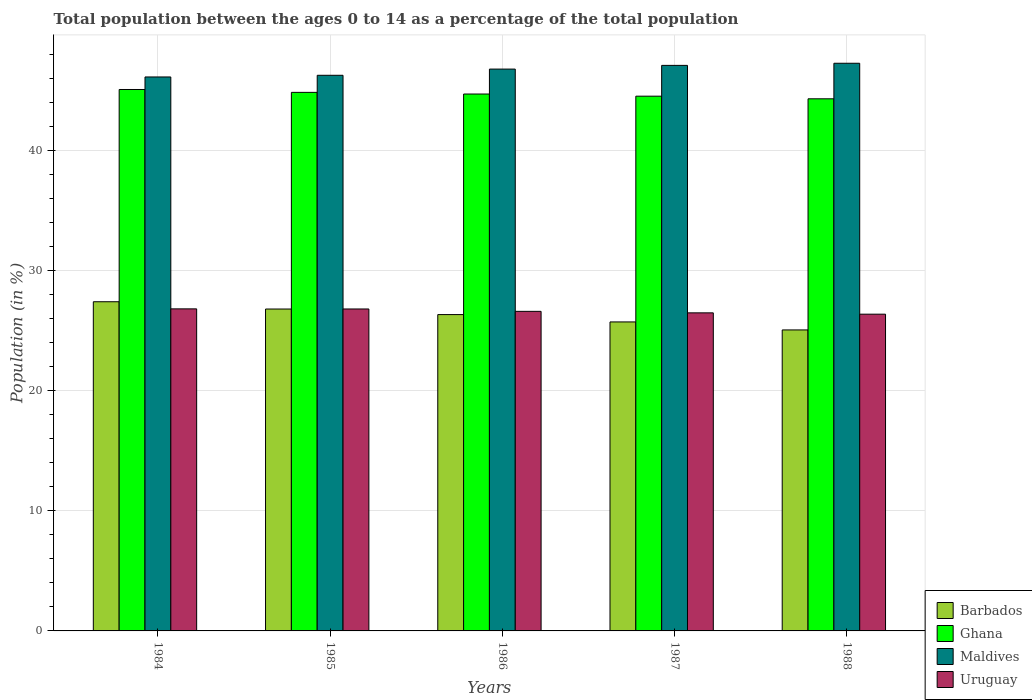How many different coloured bars are there?
Keep it short and to the point. 4. How many groups of bars are there?
Keep it short and to the point. 5. In how many cases, is the number of bars for a given year not equal to the number of legend labels?
Offer a very short reply. 0. What is the percentage of the population ages 0 to 14 in Ghana in 1984?
Ensure brevity in your answer.  45.09. Across all years, what is the maximum percentage of the population ages 0 to 14 in Barbados?
Ensure brevity in your answer.  27.42. Across all years, what is the minimum percentage of the population ages 0 to 14 in Ghana?
Your answer should be compact. 44.32. What is the total percentage of the population ages 0 to 14 in Uruguay in the graph?
Give a very brief answer. 133.13. What is the difference between the percentage of the population ages 0 to 14 in Ghana in 1987 and that in 1988?
Your answer should be compact. 0.22. What is the difference between the percentage of the population ages 0 to 14 in Barbados in 1987 and the percentage of the population ages 0 to 14 in Maldives in 1984?
Provide a short and direct response. -20.4. What is the average percentage of the population ages 0 to 14 in Barbados per year?
Your response must be concise. 26.28. In the year 1985, what is the difference between the percentage of the population ages 0 to 14 in Maldives and percentage of the population ages 0 to 14 in Uruguay?
Offer a terse response. 19.46. What is the ratio of the percentage of the population ages 0 to 14 in Ghana in 1984 to that in 1988?
Your answer should be compact. 1.02. What is the difference between the highest and the second highest percentage of the population ages 0 to 14 in Uruguay?
Give a very brief answer. 0.01. What is the difference between the highest and the lowest percentage of the population ages 0 to 14 in Uruguay?
Keep it short and to the point. 0.44. Is the sum of the percentage of the population ages 0 to 14 in Uruguay in 1985 and 1986 greater than the maximum percentage of the population ages 0 to 14 in Maldives across all years?
Ensure brevity in your answer.  Yes. Is it the case that in every year, the sum of the percentage of the population ages 0 to 14 in Barbados and percentage of the population ages 0 to 14 in Ghana is greater than the sum of percentage of the population ages 0 to 14 in Uruguay and percentage of the population ages 0 to 14 in Maldives?
Provide a succinct answer. Yes. What does the 3rd bar from the left in 1984 represents?
Keep it short and to the point. Maldives. What does the 1st bar from the right in 1985 represents?
Give a very brief answer. Uruguay. Is it the case that in every year, the sum of the percentage of the population ages 0 to 14 in Barbados and percentage of the population ages 0 to 14 in Ghana is greater than the percentage of the population ages 0 to 14 in Maldives?
Provide a succinct answer. Yes. How many years are there in the graph?
Keep it short and to the point. 5. Does the graph contain any zero values?
Your answer should be very brief. No. Where does the legend appear in the graph?
Provide a short and direct response. Bottom right. How many legend labels are there?
Provide a short and direct response. 4. What is the title of the graph?
Offer a very short reply. Total population between the ages 0 to 14 as a percentage of the total population. Does "Cabo Verde" appear as one of the legend labels in the graph?
Offer a terse response. No. What is the Population (in %) in Barbados in 1984?
Ensure brevity in your answer.  27.42. What is the Population (in %) in Ghana in 1984?
Your answer should be very brief. 45.09. What is the Population (in %) of Maldives in 1984?
Your response must be concise. 46.14. What is the Population (in %) of Uruguay in 1984?
Provide a short and direct response. 26.82. What is the Population (in %) of Barbados in 1985?
Give a very brief answer. 26.81. What is the Population (in %) of Ghana in 1985?
Provide a succinct answer. 44.86. What is the Population (in %) in Maldives in 1985?
Your response must be concise. 46.28. What is the Population (in %) of Uruguay in 1985?
Offer a very short reply. 26.81. What is the Population (in %) of Barbados in 1986?
Offer a terse response. 26.35. What is the Population (in %) in Ghana in 1986?
Provide a succinct answer. 44.72. What is the Population (in %) of Maldives in 1986?
Offer a very short reply. 46.79. What is the Population (in %) in Uruguay in 1986?
Give a very brief answer. 26.62. What is the Population (in %) in Barbados in 1987?
Your response must be concise. 25.74. What is the Population (in %) of Ghana in 1987?
Your response must be concise. 44.54. What is the Population (in %) in Maldives in 1987?
Provide a short and direct response. 47.1. What is the Population (in %) in Uruguay in 1987?
Keep it short and to the point. 26.49. What is the Population (in %) of Barbados in 1988?
Ensure brevity in your answer.  25.07. What is the Population (in %) of Ghana in 1988?
Your answer should be very brief. 44.32. What is the Population (in %) of Maldives in 1988?
Make the answer very short. 47.28. What is the Population (in %) in Uruguay in 1988?
Make the answer very short. 26.38. Across all years, what is the maximum Population (in %) of Barbados?
Provide a succinct answer. 27.42. Across all years, what is the maximum Population (in %) of Ghana?
Give a very brief answer. 45.09. Across all years, what is the maximum Population (in %) in Maldives?
Offer a very short reply. 47.28. Across all years, what is the maximum Population (in %) in Uruguay?
Offer a terse response. 26.82. Across all years, what is the minimum Population (in %) of Barbados?
Your answer should be compact. 25.07. Across all years, what is the minimum Population (in %) in Ghana?
Your answer should be compact. 44.32. Across all years, what is the minimum Population (in %) in Maldives?
Ensure brevity in your answer.  46.14. Across all years, what is the minimum Population (in %) in Uruguay?
Offer a very short reply. 26.38. What is the total Population (in %) in Barbados in the graph?
Give a very brief answer. 131.38. What is the total Population (in %) of Ghana in the graph?
Make the answer very short. 223.52. What is the total Population (in %) of Maldives in the graph?
Your answer should be compact. 233.59. What is the total Population (in %) in Uruguay in the graph?
Your answer should be compact. 133.13. What is the difference between the Population (in %) in Barbados in 1984 and that in 1985?
Keep it short and to the point. 0.61. What is the difference between the Population (in %) in Ghana in 1984 and that in 1985?
Give a very brief answer. 0.24. What is the difference between the Population (in %) of Maldives in 1984 and that in 1985?
Provide a short and direct response. -0.14. What is the difference between the Population (in %) in Uruguay in 1984 and that in 1985?
Offer a very short reply. 0.01. What is the difference between the Population (in %) of Barbados in 1984 and that in 1986?
Your answer should be very brief. 1.07. What is the difference between the Population (in %) of Ghana in 1984 and that in 1986?
Provide a short and direct response. 0.38. What is the difference between the Population (in %) of Maldives in 1984 and that in 1986?
Your response must be concise. -0.66. What is the difference between the Population (in %) of Uruguay in 1984 and that in 1986?
Make the answer very short. 0.21. What is the difference between the Population (in %) of Barbados in 1984 and that in 1987?
Ensure brevity in your answer.  1.68. What is the difference between the Population (in %) in Ghana in 1984 and that in 1987?
Provide a short and direct response. 0.56. What is the difference between the Population (in %) of Maldives in 1984 and that in 1987?
Your response must be concise. -0.96. What is the difference between the Population (in %) in Uruguay in 1984 and that in 1987?
Provide a succinct answer. 0.33. What is the difference between the Population (in %) of Barbados in 1984 and that in 1988?
Your response must be concise. 2.35. What is the difference between the Population (in %) of Ghana in 1984 and that in 1988?
Provide a succinct answer. 0.78. What is the difference between the Population (in %) in Maldives in 1984 and that in 1988?
Keep it short and to the point. -1.14. What is the difference between the Population (in %) in Uruguay in 1984 and that in 1988?
Your answer should be very brief. 0.44. What is the difference between the Population (in %) in Barbados in 1985 and that in 1986?
Your response must be concise. 0.46. What is the difference between the Population (in %) in Ghana in 1985 and that in 1986?
Provide a succinct answer. 0.14. What is the difference between the Population (in %) in Maldives in 1985 and that in 1986?
Ensure brevity in your answer.  -0.52. What is the difference between the Population (in %) of Uruguay in 1985 and that in 1986?
Offer a terse response. 0.2. What is the difference between the Population (in %) in Barbados in 1985 and that in 1987?
Your response must be concise. 1.07. What is the difference between the Population (in %) in Ghana in 1985 and that in 1987?
Offer a very short reply. 0.32. What is the difference between the Population (in %) of Maldives in 1985 and that in 1987?
Provide a succinct answer. -0.82. What is the difference between the Population (in %) of Uruguay in 1985 and that in 1987?
Make the answer very short. 0.32. What is the difference between the Population (in %) in Barbados in 1985 and that in 1988?
Give a very brief answer. 1.74. What is the difference between the Population (in %) in Ghana in 1985 and that in 1988?
Your response must be concise. 0.54. What is the difference between the Population (in %) of Maldives in 1985 and that in 1988?
Offer a very short reply. -1. What is the difference between the Population (in %) in Uruguay in 1985 and that in 1988?
Provide a succinct answer. 0.43. What is the difference between the Population (in %) of Barbados in 1986 and that in 1987?
Provide a succinct answer. 0.61. What is the difference between the Population (in %) in Ghana in 1986 and that in 1987?
Ensure brevity in your answer.  0.18. What is the difference between the Population (in %) in Maldives in 1986 and that in 1987?
Keep it short and to the point. -0.31. What is the difference between the Population (in %) of Uruguay in 1986 and that in 1987?
Make the answer very short. 0.12. What is the difference between the Population (in %) of Barbados in 1986 and that in 1988?
Your answer should be very brief. 1.28. What is the difference between the Population (in %) in Ghana in 1986 and that in 1988?
Offer a very short reply. 0.4. What is the difference between the Population (in %) in Maldives in 1986 and that in 1988?
Offer a very short reply. -0.49. What is the difference between the Population (in %) in Uruguay in 1986 and that in 1988?
Provide a succinct answer. 0.23. What is the difference between the Population (in %) of Barbados in 1987 and that in 1988?
Your answer should be compact. 0.67. What is the difference between the Population (in %) of Ghana in 1987 and that in 1988?
Your answer should be compact. 0.22. What is the difference between the Population (in %) in Maldives in 1987 and that in 1988?
Make the answer very short. -0.18. What is the difference between the Population (in %) in Uruguay in 1987 and that in 1988?
Provide a short and direct response. 0.11. What is the difference between the Population (in %) in Barbados in 1984 and the Population (in %) in Ghana in 1985?
Your response must be concise. -17.44. What is the difference between the Population (in %) in Barbados in 1984 and the Population (in %) in Maldives in 1985?
Your response must be concise. -18.86. What is the difference between the Population (in %) in Barbados in 1984 and the Population (in %) in Uruguay in 1985?
Provide a short and direct response. 0.6. What is the difference between the Population (in %) of Ghana in 1984 and the Population (in %) of Maldives in 1985?
Provide a short and direct response. -1.18. What is the difference between the Population (in %) in Ghana in 1984 and the Population (in %) in Uruguay in 1985?
Your answer should be compact. 18.28. What is the difference between the Population (in %) of Maldives in 1984 and the Population (in %) of Uruguay in 1985?
Make the answer very short. 19.32. What is the difference between the Population (in %) of Barbados in 1984 and the Population (in %) of Ghana in 1986?
Your answer should be very brief. -17.3. What is the difference between the Population (in %) of Barbados in 1984 and the Population (in %) of Maldives in 1986?
Provide a succinct answer. -19.38. What is the difference between the Population (in %) in Barbados in 1984 and the Population (in %) in Uruguay in 1986?
Ensure brevity in your answer.  0.8. What is the difference between the Population (in %) of Ghana in 1984 and the Population (in %) of Maldives in 1986?
Offer a very short reply. -1.7. What is the difference between the Population (in %) in Ghana in 1984 and the Population (in %) in Uruguay in 1986?
Keep it short and to the point. 18.48. What is the difference between the Population (in %) in Maldives in 1984 and the Population (in %) in Uruguay in 1986?
Make the answer very short. 19.52. What is the difference between the Population (in %) in Barbados in 1984 and the Population (in %) in Ghana in 1987?
Give a very brief answer. -17.12. What is the difference between the Population (in %) of Barbados in 1984 and the Population (in %) of Maldives in 1987?
Offer a terse response. -19.69. What is the difference between the Population (in %) in Barbados in 1984 and the Population (in %) in Uruguay in 1987?
Offer a terse response. 0.93. What is the difference between the Population (in %) in Ghana in 1984 and the Population (in %) in Maldives in 1987?
Offer a very short reply. -2.01. What is the difference between the Population (in %) of Ghana in 1984 and the Population (in %) of Uruguay in 1987?
Keep it short and to the point. 18.6. What is the difference between the Population (in %) of Maldives in 1984 and the Population (in %) of Uruguay in 1987?
Your answer should be compact. 19.65. What is the difference between the Population (in %) of Barbados in 1984 and the Population (in %) of Ghana in 1988?
Offer a very short reply. -16.9. What is the difference between the Population (in %) of Barbados in 1984 and the Population (in %) of Maldives in 1988?
Make the answer very short. -19.86. What is the difference between the Population (in %) in Barbados in 1984 and the Population (in %) in Uruguay in 1988?
Your answer should be compact. 1.04. What is the difference between the Population (in %) of Ghana in 1984 and the Population (in %) of Maldives in 1988?
Offer a very short reply. -2.19. What is the difference between the Population (in %) of Ghana in 1984 and the Population (in %) of Uruguay in 1988?
Provide a short and direct response. 18.71. What is the difference between the Population (in %) of Maldives in 1984 and the Population (in %) of Uruguay in 1988?
Offer a very short reply. 19.76. What is the difference between the Population (in %) in Barbados in 1985 and the Population (in %) in Ghana in 1986?
Ensure brevity in your answer.  -17.91. What is the difference between the Population (in %) of Barbados in 1985 and the Population (in %) of Maldives in 1986?
Offer a terse response. -19.98. What is the difference between the Population (in %) of Barbados in 1985 and the Population (in %) of Uruguay in 1986?
Your answer should be very brief. 0.19. What is the difference between the Population (in %) in Ghana in 1985 and the Population (in %) in Maldives in 1986?
Ensure brevity in your answer.  -1.94. What is the difference between the Population (in %) of Ghana in 1985 and the Population (in %) of Uruguay in 1986?
Provide a succinct answer. 18.24. What is the difference between the Population (in %) in Maldives in 1985 and the Population (in %) in Uruguay in 1986?
Offer a terse response. 19.66. What is the difference between the Population (in %) of Barbados in 1985 and the Population (in %) of Ghana in 1987?
Provide a succinct answer. -17.73. What is the difference between the Population (in %) of Barbados in 1985 and the Population (in %) of Maldives in 1987?
Keep it short and to the point. -20.29. What is the difference between the Population (in %) in Barbados in 1985 and the Population (in %) in Uruguay in 1987?
Offer a terse response. 0.32. What is the difference between the Population (in %) of Ghana in 1985 and the Population (in %) of Maldives in 1987?
Ensure brevity in your answer.  -2.25. What is the difference between the Population (in %) in Ghana in 1985 and the Population (in %) in Uruguay in 1987?
Your response must be concise. 18.36. What is the difference between the Population (in %) of Maldives in 1985 and the Population (in %) of Uruguay in 1987?
Keep it short and to the point. 19.79. What is the difference between the Population (in %) in Barbados in 1985 and the Population (in %) in Ghana in 1988?
Keep it short and to the point. -17.51. What is the difference between the Population (in %) in Barbados in 1985 and the Population (in %) in Maldives in 1988?
Your answer should be compact. -20.47. What is the difference between the Population (in %) in Barbados in 1985 and the Population (in %) in Uruguay in 1988?
Provide a succinct answer. 0.43. What is the difference between the Population (in %) of Ghana in 1985 and the Population (in %) of Maldives in 1988?
Your response must be concise. -2.42. What is the difference between the Population (in %) of Ghana in 1985 and the Population (in %) of Uruguay in 1988?
Provide a succinct answer. 18.47. What is the difference between the Population (in %) in Maldives in 1985 and the Population (in %) in Uruguay in 1988?
Offer a very short reply. 19.9. What is the difference between the Population (in %) of Barbados in 1986 and the Population (in %) of Ghana in 1987?
Make the answer very short. -18.19. What is the difference between the Population (in %) of Barbados in 1986 and the Population (in %) of Maldives in 1987?
Provide a succinct answer. -20.76. What is the difference between the Population (in %) of Barbados in 1986 and the Population (in %) of Uruguay in 1987?
Provide a short and direct response. -0.14. What is the difference between the Population (in %) in Ghana in 1986 and the Population (in %) in Maldives in 1987?
Provide a succinct answer. -2.38. What is the difference between the Population (in %) of Ghana in 1986 and the Population (in %) of Uruguay in 1987?
Make the answer very short. 18.23. What is the difference between the Population (in %) in Maldives in 1986 and the Population (in %) in Uruguay in 1987?
Your answer should be very brief. 20.3. What is the difference between the Population (in %) of Barbados in 1986 and the Population (in %) of Ghana in 1988?
Your answer should be very brief. -17.97. What is the difference between the Population (in %) in Barbados in 1986 and the Population (in %) in Maldives in 1988?
Ensure brevity in your answer.  -20.93. What is the difference between the Population (in %) of Barbados in 1986 and the Population (in %) of Uruguay in 1988?
Your answer should be compact. -0.03. What is the difference between the Population (in %) in Ghana in 1986 and the Population (in %) in Maldives in 1988?
Provide a short and direct response. -2.56. What is the difference between the Population (in %) in Ghana in 1986 and the Population (in %) in Uruguay in 1988?
Your answer should be compact. 18.34. What is the difference between the Population (in %) in Maldives in 1986 and the Population (in %) in Uruguay in 1988?
Keep it short and to the point. 20.41. What is the difference between the Population (in %) of Barbados in 1987 and the Population (in %) of Ghana in 1988?
Your answer should be compact. -18.58. What is the difference between the Population (in %) of Barbados in 1987 and the Population (in %) of Maldives in 1988?
Your response must be concise. -21.54. What is the difference between the Population (in %) in Barbados in 1987 and the Population (in %) in Uruguay in 1988?
Your answer should be very brief. -0.65. What is the difference between the Population (in %) in Ghana in 1987 and the Population (in %) in Maldives in 1988?
Provide a short and direct response. -2.74. What is the difference between the Population (in %) in Ghana in 1987 and the Population (in %) in Uruguay in 1988?
Provide a short and direct response. 18.16. What is the difference between the Population (in %) in Maldives in 1987 and the Population (in %) in Uruguay in 1988?
Give a very brief answer. 20.72. What is the average Population (in %) in Barbados per year?
Your response must be concise. 26.28. What is the average Population (in %) in Ghana per year?
Give a very brief answer. 44.7. What is the average Population (in %) of Maldives per year?
Offer a very short reply. 46.72. What is the average Population (in %) of Uruguay per year?
Keep it short and to the point. 26.63. In the year 1984, what is the difference between the Population (in %) of Barbados and Population (in %) of Ghana?
Your answer should be very brief. -17.68. In the year 1984, what is the difference between the Population (in %) in Barbados and Population (in %) in Maldives?
Give a very brief answer. -18.72. In the year 1984, what is the difference between the Population (in %) of Barbados and Population (in %) of Uruguay?
Give a very brief answer. 0.59. In the year 1984, what is the difference between the Population (in %) in Ghana and Population (in %) in Maldives?
Your answer should be very brief. -1.04. In the year 1984, what is the difference between the Population (in %) of Ghana and Population (in %) of Uruguay?
Keep it short and to the point. 18.27. In the year 1984, what is the difference between the Population (in %) of Maldives and Population (in %) of Uruguay?
Your answer should be compact. 19.31. In the year 1985, what is the difference between the Population (in %) of Barbados and Population (in %) of Ghana?
Offer a terse response. -18.05. In the year 1985, what is the difference between the Population (in %) of Barbados and Population (in %) of Maldives?
Offer a very short reply. -19.47. In the year 1985, what is the difference between the Population (in %) in Barbados and Population (in %) in Uruguay?
Provide a short and direct response. -0. In the year 1985, what is the difference between the Population (in %) in Ghana and Population (in %) in Maldives?
Keep it short and to the point. -1.42. In the year 1985, what is the difference between the Population (in %) of Ghana and Population (in %) of Uruguay?
Your answer should be compact. 18.04. In the year 1985, what is the difference between the Population (in %) of Maldives and Population (in %) of Uruguay?
Make the answer very short. 19.46. In the year 1986, what is the difference between the Population (in %) of Barbados and Population (in %) of Ghana?
Offer a terse response. -18.37. In the year 1986, what is the difference between the Population (in %) in Barbados and Population (in %) in Maldives?
Provide a succinct answer. -20.45. In the year 1986, what is the difference between the Population (in %) in Barbados and Population (in %) in Uruguay?
Keep it short and to the point. -0.27. In the year 1986, what is the difference between the Population (in %) of Ghana and Population (in %) of Maldives?
Provide a short and direct response. -2.08. In the year 1986, what is the difference between the Population (in %) in Ghana and Population (in %) in Uruguay?
Provide a succinct answer. 18.1. In the year 1986, what is the difference between the Population (in %) of Maldives and Population (in %) of Uruguay?
Offer a very short reply. 20.18. In the year 1987, what is the difference between the Population (in %) in Barbados and Population (in %) in Ghana?
Ensure brevity in your answer.  -18.8. In the year 1987, what is the difference between the Population (in %) in Barbados and Population (in %) in Maldives?
Provide a succinct answer. -21.37. In the year 1987, what is the difference between the Population (in %) in Barbados and Population (in %) in Uruguay?
Your answer should be very brief. -0.76. In the year 1987, what is the difference between the Population (in %) of Ghana and Population (in %) of Maldives?
Ensure brevity in your answer.  -2.57. In the year 1987, what is the difference between the Population (in %) in Ghana and Population (in %) in Uruguay?
Give a very brief answer. 18.05. In the year 1987, what is the difference between the Population (in %) of Maldives and Population (in %) of Uruguay?
Make the answer very short. 20.61. In the year 1988, what is the difference between the Population (in %) of Barbados and Population (in %) of Ghana?
Your response must be concise. -19.25. In the year 1988, what is the difference between the Population (in %) of Barbados and Population (in %) of Maldives?
Ensure brevity in your answer.  -22.21. In the year 1988, what is the difference between the Population (in %) in Barbados and Population (in %) in Uruguay?
Offer a terse response. -1.31. In the year 1988, what is the difference between the Population (in %) of Ghana and Population (in %) of Maldives?
Provide a short and direct response. -2.96. In the year 1988, what is the difference between the Population (in %) in Ghana and Population (in %) in Uruguay?
Offer a very short reply. 17.94. In the year 1988, what is the difference between the Population (in %) of Maldives and Population (in %) of Uruguay?
Offer a very short reply. 20.9. What is the ratio of the Population (in %) in Barbados in 1984 to that in 1985?
Keep it short and to the point. 1.02. What is the ratio of the Population (in %) in Barbados in 1984 to that in 1986?
Offer a terse response. 1.04. What is the ratio of the Population (in %) of Ghana in 1984 to that in 1986?
Offer a very short reply. 1.01. What is the ratio of the Population (in %) of Maldives in 1984 to that in 1986?
Provide a succinct answer. 0.99. What is the ratio of the Population (in %) in Uruguay in 1984 to that in 1986?
Ensure brevity in your answer.  1.01. What is the ratio of the Population (in %) in Barbados in 1984 to that in 1987?
Make the answer very short. 1.07. What is the ratio of the Population (in %) of Ghana in 1984 to that in 1987?
Offer a very short reply. 1.01. What is the ratio of the Population (in %) in Maldives in 1984 to that in 1987?
Ensure brevity in your answer.  0.98. What is the ratio of the Population (in %) of Uruguay in 1984 to that in 1987?
Provide a succinct answer. 1.01. What is the ratio of the Population (in %) in Barbados in 1984 to that in 1988?
Your response must be concise. 1.09. What is the ratio of the Population (in %) of Ghana in 1984 to that in 1988?
Provide a short and direct response. 1.02. What is the ratio of the Population (in %) of Maldives in 1984 to that in 1988?
Your response must be concise. 0.98. What is the ratio of the Population (in %) in Uruguay in 1984 to that in 1988?
Offer a terse response. 1.02. What is the ratio of the Population (in %) of Barbados in 1985 to that in 1986?
Your answer should be very brief. 1.02. What is the ratio of the Population (in %) of Ghana in 1985 to that in 1986?
Your response must be concise. 1. What is the ratio of the Population (in %) in Maldives in 1985 to that in 1986?
Your answer should be very brief. 0.99. What is the ratio of the Population (in %) in Uruguay in 1985 to that in 1986?
Ensure brevity in your answer.  1.01. What is the ratio of the Population (in %) in Barbados in 1985 to that in 1987?
Your answer should be very brief. 1.04. What is the ratio of the Population (in %) of Ghana in 1985 to that in 1987?
Your answer should be compact. 1.01. What is the ratio of the Population (in %) of Maldives in 1985 to that in 1987?
Keep it short and to the point. 0.98. What is the ratio of the Population (in %) of Uruguay in 1985 to that in 1987?
Your answer should be compact. 1.01. What is the ratio of the Population (in %) in Barbados in 1985 to that in 1988?
Your response must be concise. 1.07. What is the ratio of the Population (in %) of Ghana in 1985 to that in 1988?
Give a very brief answer. 1.01. What is the ratio of the Population (in %) of Maldives in 1985 to that in 1988?
Keep it short and to the point. 0.98. What is the ratio of the Population (in %) of Uruguay in 1985 to that in 1988?
Your answer should be very brief. 1.02. What is the ratio of the Population (in %) of Barbados in 1986 to that in 1987?
Your answer should be compact. 1.02. What is the ratio of the Population (in %) of Maldives in 1986 to that in 1987?
Your answer should be very brief. 0.99. What is the ratio of the Population (in %) of Uruguay in 1986 to that in 1987?
Offer a terse response. 1. What is the ratio of the Population (in %) in Barbados in 1986 to that in 1988?
Your response must be concise. 1.05. What is the ratio of the Population (in %) of Uruguay in 1986 to that in 1988?
Your response must be concise. 1.01. What is the ratio of the Population (in %) of Barbados in 1987 to that in 1988?
Give a very brief answer. 1.03. What is the ratio of the Population (in %) in Maldives in 1987 to that in 1988?
Offer a terse response. 1. What is the difference between the highest and the second highest Population (in %) in Barbados?
Offer a terse response. 0.61. What is the difference between the highest and the second highest Population (in %) in Ghana?
Provide a short and direct response. 0.24. What is the difference between the highest and the second highest Population (in %) in Maldives?
Your answer should be very brief. 0.18. What is the difference between the highest and the second highest Population (in %) in Uruguay?
Your answer should be very brief. 0.01. What is the difference between the highest and the lowest Population (in %) of Barbados?
Provide a short and direct response. 2.35. What is the difference between the highest and the lowest Population (in %) in Ghana?
Offer a terse response. 0.78. What is the difference between the highest and the lowest Population (in %) in Maldives?
Make the answer very short. 1.14. What is the difference between the highest and the lowest Population (in %) of Uruguay?
Offer a very short reply. 0.44. 